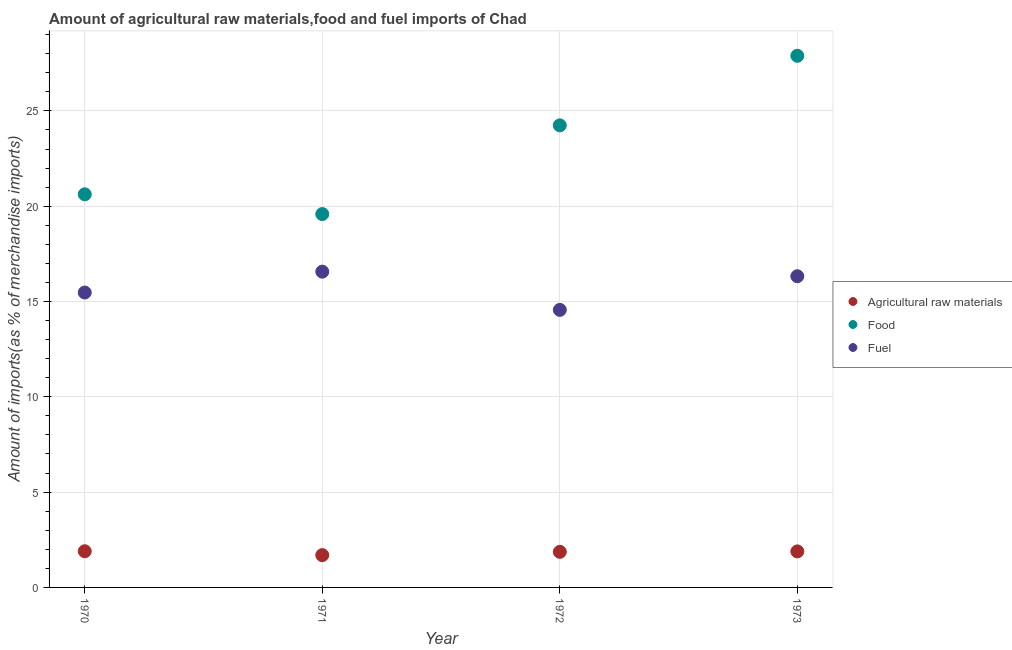How many different coloured dotlines are there?
Provide a succinct answer. 3. What is the percentage of raw materials imports in 1972?
Make the answer very short. 1.87. Across all years, what is the maximum percentage of fuel imports?
Your answer should be very brief. 16.57. Across all years, what is the minimum percentage of fuel imports?
Provide a succinct answer. 14.56. What is the total percentage of food imports in the graph?
Offer a very short reply. 92.35. What is the difference between the percentage of food imports in 1970 and that in 1973?
Ensure brevity in your answer.  -7.27. What is the difference between the percentage of fuel imports in 1970 and the percentage of raw materials imports in 1971?
Offer a very short reply. 13.78. What is the average percentage of raw materials imports per year?
Give a very brief answer. 1.84. In the year 1972, what is the difference between the percentage of food imports and percentage of raw materials imports?
Ensure brevity in your answer.  22.37. What is the ratio of the percentage of fuel imports in 1970 to that in 1971?
Offer a terse response. 0.93. Is the percentage of food imports in 1970 less than that in 1973?
Your response must be concise. Yes. Is the difference between the percentage of food imports in 1972 and 1973 greater than the difference between the percentage of raw materials imports in 1972 and 1973?
Provide a succinct answer. No. What is the difference between the highest and the second highest percentage of food imports?
Offer a terse response. 3.65. What is the difference between the highest and the lowest percentage of fuel imports?
Provide a short and direct response. 2.01. In how many years, is the percentage of fuel imports greater than the average percentage of fuel imports taken over all years?
Give a very brief answer. 2. Is the sum of the percentage of raw materials imports in 1970 and 1973 greater than the maximum percentage of food imports across all years?
Keep it short and to the point. No. Is it the case that in every year, the sum of the percentage of raw materials imports and percentage of food imports is greater than the percentage of fuel imports?
Your response must be concise. Yes. How many dotlines are there?
Your answer should be very brief. 3. Does the graph contain any zero values?
Keep it short and to the point. No. What is the title of the graph?
Give a very brief answer. Amount of agricultural raw materials,food and fuel imports of Chad. Does "Primary education" appear as one of the legend labels in the graph?
Keep it short and to the point. No. What is the label or title of the X-axis?
Make the answer very short. Year. What is the label or title of the Y-axis?
Make the answer very short. Amount of imports(as % of merchandise imports). What is the Amount of imports(as % of merchandise imports) in Agricultural raw materials in 1970?
Offer a very short reply. 1.9. What is the Amount of imports(as % of merchandise imports) of Food in 1970?
Offer a very short reply. 20.63. What is the Amount of imports(as % of merchandise imports) of Fuel in 1970?
Give a very brief answer. 15.47. What is the Amount of imports(as % of merchandise imports) in Agricultural raw materials in 1971?
Provide a short and direct response. 1.69. What is the Amount of imports(as % of merchandise imports) in Food in 1971?
Your answer should be compact. 19.59. What is the Amount of imports(as % of merchandise imports) in Fuel in 1971?
Give a very brief answer. 16.57. What is the Amount of imports(as % of merchandise imports) in Agricultural raw materials in 1972?
Your answer should be very brief. 1.87. What is the Amount of imports(as % of merchandise imports) of Food in 1972?
Your response must be concise. 24.24. What is the Amount of imports(as % of merchandise imports) in Fuel in 1972?
Give a very brief answer. 14.56. What is the Amount of imports(as % of merchandise imports) of Agricultural raw materials in 1973?
Provide a short and direct response. 1.89. What is the Amount of imports(as % of merchandise imports) of Food in 1973?
Ensure brevity in your answer.  27.89. What is the Amount of imports(as % of merchandise imports) of Fuel in 1973?
Provide a short and direct response. 16.33. Across all years, what is the maximum Amount of imports(as % of merchandise imports) of Agricultural raw materials?
Your answer should be very brief. 1.9. Across all years, what is the maximum Amount of imports(as % of merchandise imports) in Food?
Keep it short and to the point. 27.89. Across all years, what is the maximum Amount of imports(as % of merchandise imports) in Fuel?
Give a very brief answer. 16.57. Across all years, what is the minimum Amount of imports(as % of merchandise imports) of Agricultural raw materials?
Your answer should be compact. 1.69. Across all years, what is the minimum Amount of imports(as % of merchandise imports) of Food?
Keep it short and to the point. 19.59. Across all years, what is the minimum Amount of imports(as % of merchandise imports) of Fuel?
Make the answer very short. 14.56. What is the total Amount of imports(as % of merchandise imports) of Agricultural raw materials in the graph?
Offer a terse response. 7.35. What is the total Amount of imports(as % of merchandise imports) of Food in the graph?
Your answer should be very brief. 92.35. What is the total Amount of imports(as % of merchandise imports) of Fuel in the graph?
Give a very brief answer. 62.92. What is the difference between the Amount of imports(as % of merchandise imports) of Agricultural raw materials in 1970 and that in 1971?
Keep it short and to the point. 0.2. What is the difference between the Amount of imports(as % of merchandise imports) of Food in 1970 and that in 1971?
Ensure brevity in your answer.  1.04. What is the difference between the Amount of imports(as % of merchandise imports) of Fuel in 1970 and that in 1971?
Give a very brief answer. -1.1. What is the difference between the Amount of imports(as % of merchandise imports) in Agricultural raw materials in 1970 and that in 1972?
Your answer should be very brief. 0.03. What is the difference between the Amount of imports(as % of merchandise imports) of Food in 1970 and that in 1972?
Provide a short and direct response. -3.62. What is the difference between the Amount of imports(as % of merchandise imports) of Fuel in 1970 and that in 1972?
Provide a short and direct response. 0.91. What is the difference between the Amount of imports(as % of merchandise imports) in Agricultural raw materials in 1970 and that in 1973?
Offer a terse response. 0.01. What is the difference between the Amount of imports(as % of merchandise imports) of Food in 1970 and that in 1973?
Provide a short and direct response. -7.27. What is the difference between the Amount of imports(as % of merchandise imports) in Fuel in 1970 and that in 1973?
Your answer should be very brief. -0.86. What is the difference between the Amount of imports(as % of merchandise imports) of Agricultural raw materials in 1971 and that in 1972?
Provide a short and direct response. -0.17. What is the difference between the Amount of imports(as % of merchandise imports) of Food in 1971 and that in 1972?
Ensure brevity in your answer.  -4.65. What is the difference between the Amount of imports(as % of merchandise imports) of Fuel in 1971 and that in 1972?
Provide a short and direct response. 2.01. What is the difference between the Amount of imports(as % of merchandise imports) in Agricultural raw materials in 1971 and that in 1973?
Give a very brief answer. -0.2. What is the difference between the Amount of imports(as % of merchandise imports) in Food in 1971 and that in 1973?
Your answer should be compact. -8.3. What is the difference between the Amount of imports(as % of merchandise imports) of Fuel in 1971 and that in 1973?
Your response must be concise. 0.24. What is the difference between the Amount of imports(as % of merchandise imports) in Agricultural raw materials in 1972 and that in 1973?
Ensure brevity in your answer.  -0.02. What is the difference between the Amount of imports(as % of merchandise imports) in Food in 1972 and that in 1973?
Give a very brief answer. -3.65. What is the difference between the Amount of imports(as % of merchandise imports) in Fuel in 1972 and that in 1973?
Make the answer very short. -1.77. What is the difference between the Amount of imports(as % of merchandise imports) in Agricultural raw materials in 1970 and the Amount of imports(as % of merchandise imports) in Food in 1971?
Ensure brevity in your answer.  -17.69. What is the difference between the Amount of imports(as % of merchandise imports) of Agricultural raw materials in 1970 and the Amount of imports(as % of merchandise imports) of Fuel in 1971?
Provide a succinct answer. -14.67. What is the difference between the Amount of imports(as % of merchandise imports) of Food in 1970 and the Amount of imports(as % of merchandise imports) of Fuel in 1971?
Give a very brief answer. 4.06. What is the difference between the Amount of imports(as % of merchandise imports) in Agricultural raw materials in 1970 and the Amount of imports(as % of merchandise imports) in Food in 1972?
Keep it short and to the point. -22.34. What is the difference between the Amount of imports(as % of merchandise imports) of Agricultural raw materials in 1970 and the Amount of imports(as % of merchandise imports) of Fuel in 1972?
Your answer should be compact. -12.66. What is the difference between the Amount of imports(as % of merchandise imports) of Food in 1970 and the Amount of imports(as % of merchandise imports) of Fuel in 1972?
Give a very brief answer. 6.06. What is the difference between the Amount of imports(as % of merchandise imports) in Agricultural raw materials in 1970 and the Amount of imports(as % of merchandise imports) in Food in 1973?
Your answer should be very brief. -25.99. What is the difference between the Amount of imports(as % of merchandise imports) in Agricultural raw materials in 1970 and the Amount of imports(as % of merchandise imports) in Fuel in 1973?
Give a very brief answer. -14.43. What is the difference between the Amount of imports(as % of merchandise imports) of Food in 1970 and the Amount of imports(as % of merchandise imports) of Fuel in 1973?
Your answer should be very brief. 4.3. What is the difference between the Amount of imports(as % of merchandise imports) of Agricultural raw materials in 1971 and the Amount of imports(as % of merchandise imports) of Food in 1972?
Provide a short and direct response. -22.55. What is the difference between the Amount of imports(as % of merchandise imports) in Agricultural raw materials in 1971 and the Amount of imports(as % of merchandise imports) in Fuel in 1972?
Offer a very short reply. -12.87. What is the difference between the Amount of imports(as % of merchandise imports) in Food in 1971 and the Amount of imports(as % of merchandise imports) in Fuel in 1972?
Offer a very short reply. 5.03. What is the difference between the Amount of imports(as % of merchandise imports) of Agricultural raw materials in 1971 and the Amount of imports(as % of merchandise imports) of Food in 1973?
Your answer should be compact. -26.2. What is the difference between the Amount of imports(as % of merchandise imports) of Agricultural raw materials in 1971 and the Amount of imports(as % of merchandise imports) of Fuel in 1973?
Make the answer very short. -14.63. What is the difference between the Amount of imports(as % of merchandise imports) of Food in 1971 and the Amount of imports(as % of merchandise imports) of Fuel in 1973?
Make the answer very short. 3.26. What is the difference between the Amount of imports(as % of merchandise imports) of Agricultural raw materials in 1972 and the Amount of imports(as % of merchandise imports) of Food in 1973?
Offer a very short reply. -26.02. What is the difference between the Amount of imports(as % of merchandise imports) in Agricultural raw materials in 1972 and the Amount of imports(as % of merchandise imports) in Fuel in 1973?
Give a very brief answer. -14.46. What is the difference between the Amount of imports(as % of merchandise imports) in Food in 1972 and the Amount of imports(as % of merchandise imports) in Fuel in 1973?
Make the answer very short. 7.92. What is the average Amount of imports(as % of merchandise imports) of Agricultural raw materials per year?
Your answer should be very brief. 1.84. What is the average Amount of imports(as % of merchandise imports) of Food per year?
Ensure brevity in your answer.  23.09. What is the average Amount of imports(as % of merchandise imports) in Fuel per year?
Your answer should be very brief. 15.73. In the year 1970, what is the difference between the Amount of imports(as % of merchandise imports) of Agricultural raw materials and Amount of imports(as % of merchandise imports) of Food?
Provide a short and direct response. -18.73. In the year 1970, what is the difference between the Amount of imports(as % of merchandise imports) in Agricultural raw materials and Amount of imports(as % of merchandise imports) in Fuel?
Keep it short and to the point. -13.57. In the year 1970, what is the difference between the Amount of imports(as % of merchandise imports) in Food and Amount of imports(as % of merchandise imports) in Fuel?
Give a very brief answer. 5.15. In the year 1971, what is the difference between the Amount of imports(as % of merchandise imports) in Agricultural raw materials and Amount of imports(as % of merchandise imports) in Food?
Make the answer very short. -17.89. In the year 1971, what is the difference between the Amount of imports(as % of merchandise imports) of Agricultural raw materials and Amount of imports(as % of merchandise imports) of Fuel?
Make the answer very short. -14.87. In the year 1971, what is the difference between the Amount of imports(as % of merchandise imports) in Food and Amount of imports(as % of merchandise imports) in Fuel?
Ensure brevity in your answer.  3.02. In the year 1972, what is the difference between the Amount of imports(as % of merchandise imports) of Agricultural raw materials and Amount of imports(as % of merchandise imports) of Food?
Provide a succinct answer. -22.38. In the year 1972, what is the difference between the Amount of imports(as % of merchandise imports) of Agricultural raw materials and Amount of imports(as % of merchandise imports) of Fuel?
Make the answer very short. -12.69. In the year 1972, what is the difference between the Amount of imports(as % of merchandise imports) in Food and Amount of imports(as % of merchandise imports) in Fuel?
Your answer should be compact. 9.68. In the year 1973, what is the difference between the Amount of imports(as % of merchandise imports) in Agricultural raw materials and Amount of imports(as % of merchandise imports) in Food?
Your answer should be very brief. -26. In the year 1973, what is the difference between the Amount of imports(as % of merchandise imports) in Agricultural raw materials and Amount of imports(as % of merchandise imports) in Fuel?
Your answer should be very brief. -14.44. In the year 1973, what is the difference between the Amount of imports(as % of merchandise imports) in Food and Amount of imports(as % of merchandise imports) in Fuel?
Make the answer very short. 11.56. What is the ratio of the Amount of imports(as % of merchandise imports) in Agricultural raw materials in 1970 to that in 1971?
Provide a succinct answer. 1.12. What is the ratio of the Amount of imports(as % of merchandise imports) in Food in 1970 to that in 1971?
Provide a succinct answer. 1.05. What is the ratio of the Amount of imports(as % of merchandise imports) of Fuel in 1970 to that in 1971?
Offer a very short reply. 0.93. What is the ratio of the Amount of imports(as % of merchandise imports) in Agricultural raw materials in 1970 to that in 1972?
Your answer should be compact. 1.02. What is the ratio of the Amount of imports(as % of merchandise imports) of Food in 1970 to that in 1972?
Ensure brevity in your answer.  0.85. What is the ratio of the Amount of imports(as % of merchandise imports) of Agricultural raw materials in 1970 to that in 1973?
Your response must be concise. 1. What is the ratio of the Amount of imports(as % of merchandise imports) in Food in 1970 to that in 1973?
Provide a short and direct response. 0.74. What is the ratio of the Amount of imports(as % of merchandise imports) in Fuel in 1970 to that in 1973?
Ensure brevity in your answer.  0.95. What is the ratio of the Amount of imports(as % of merchandise imports) of Agricultural raw materials in 1971 to that in 1972?
Your answer should be compact. 0.91. What is the ratio of the Amount of imports(as % of merchandise imports) in Food in 1971 to that in 1972?
Give a very brief answer. 0.81. What is the ratio of the Amount of imports(as % of merchandise imports) of Fuel in 1971 to that in 1972?
Make the answer very short. 1.14. What is the ratio of the Amount of imports(as % of merchandise imports) in Agricultural raw materials in 1971 to that in 1973?
Offer a very short reply. 0.9. What is the ratio of the Amount of imports(as % of merchandise imports) of Food in 1971 to that in 1973?
Offer a very short reply. 0.7. What is the ratio of the Amount of imports(as % of merchandise imports) in Fuel in 1971 to that in 1973?
Offer a terse response. 1.01. What is the ratio of the Amount of imports(as % of merchandise imports) in Agricultural raw materials in 1972 to that in 1973?
Provide a short and direct response. 0.99. What is the ratio of the Amount of imports(as % of merchandise imports) in Food in 1972 to that in 1973?
Provide a short and direct response. 0.87. What is the ratio of the Amount of imports(as % of merchandise imports) of Fuel in 1972 to that in 1973?
Your answer should be compact. 0.89. What is the difference between the highest and the second highest Amount of imports(as % of merchandise imports) of Agricultural raw materials?
Offer a very short reply. 0.01. What is the difference between the highest and the second highest Amount of imports(as % of merchandise imports) of Food?
Your answer should be very brief. 3.65. What is the difference between the highest and the second highest Amount of imports(as % of merchandise imports) in Fuel?
Provide a succinct answer. 0.24. What is the difference between the highest and the lowest Amount of imports(as % of merchandise imports) of Agricultural raw materials?
Your answer should be very brief. 0.2. What is the difference between the highest and the lowest Amount of imports(as % of merchandise imports) in Food?
Your response must be concise. 8.3. What is the difference between the highest and the lowest Amount of imports(as % of merchandise imports) in Fuel?
Offer a terse response. 2.01. 